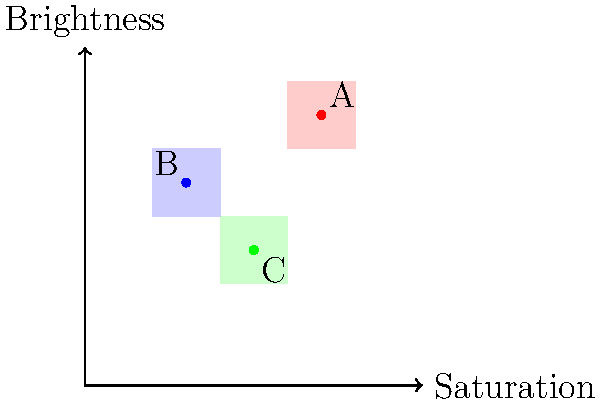In the color coordinate system shown above, three distinct cultural art styles (A, B, and C) are represented based on their characteristic use of color saturation and brightness. Which art style, according to this analysis, tends to use colors with the highest saturation and brightness values? To determine which art style uses colors with the highest saturation and brightness values, we need to analyze the position of each point in the coordinate system:

1. The x-axis represents saturation, with higher values indicating more saturated colors.
2. The y-axis represents brightness, with higher values indicating brighter colors.

Let's examine each point:

A: Located at approximately (70, 80)
B: Located at approximately (30, 60)
C: Located at approximately (50, 40)

Comparing these coordinates:

1. Saturation:
   A (70) > C (50) > B (30)

2. Brightness:
   A (80) > B (60) > C (40)

Art style A has both the highest saturation (70) and the highest brightness (80) values among the three styles represented.

Therefore, art style A tends to use colors with the highest saturation and brightness values in this comparative analysis.
Answer: A 